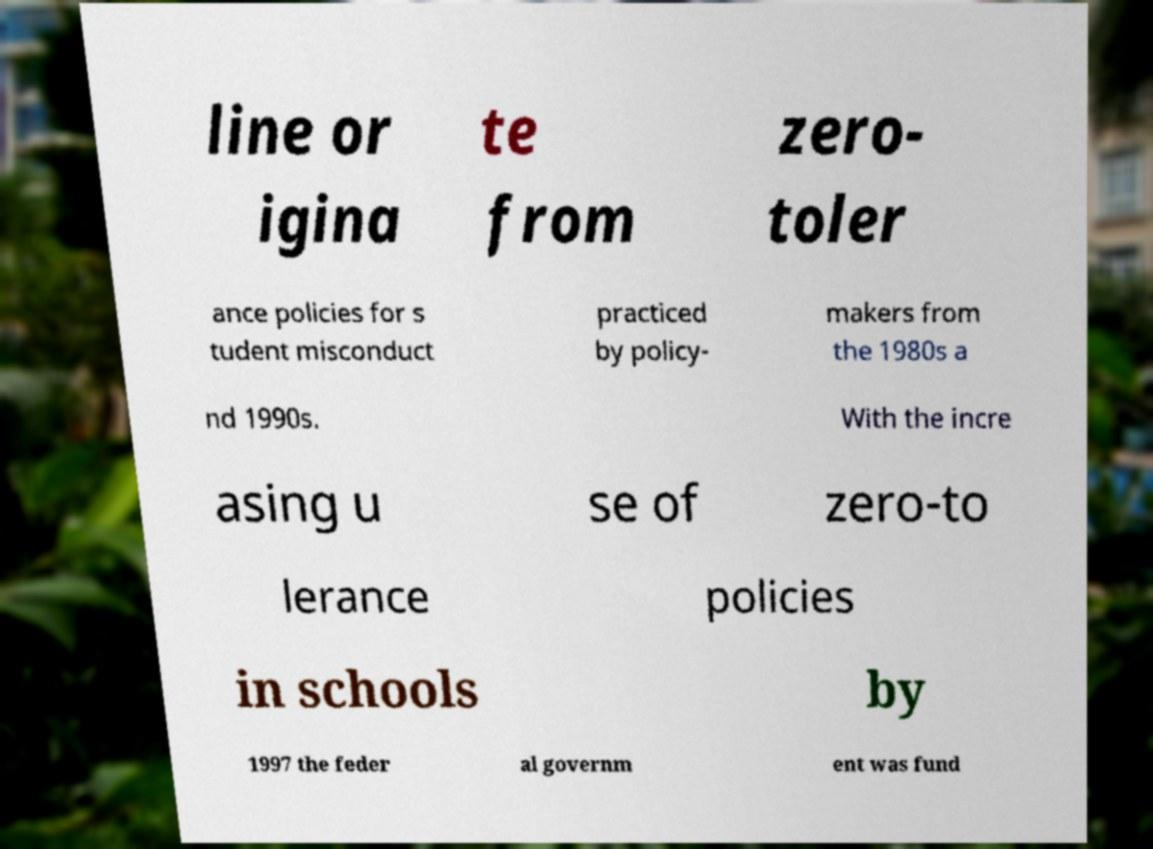Please identify and transcribe the text found in this image. line or igina te from zero- toler ance policies for s tudent misconduct practiced by policy- makers from the 1980s a nd 1990s. With the incre asing u se of zero-to lerance policies in schools by 1997 the feder al governm ent was fund 